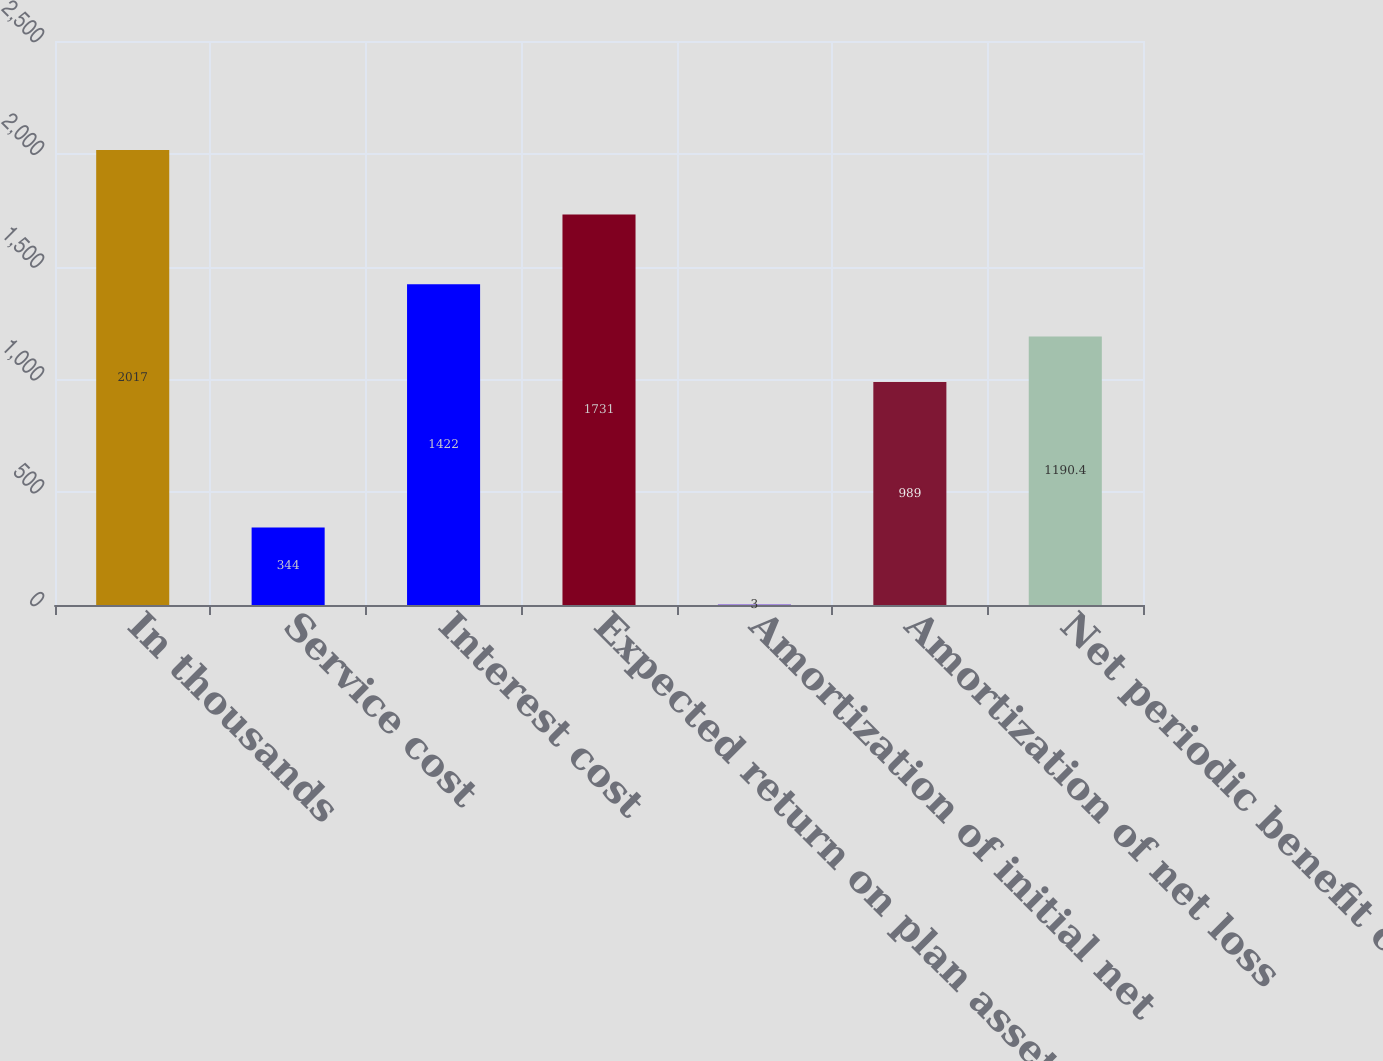Convert chart. <chart><loc_0><loc_0><loc_500><loc_500><bar_chart><fcel>In thousands<fcel>Service cost<fcel>Interest cost<fcel>Expected return on plan assets<fcel>Amortization of initial net<fcel>Amortization of net loss<fcel>Net periodic benefit cost<nl><fcel>2017<fcel>344<fcel>1422<fcel>1731<fcel>3<fcel>989<fcel>1190.4<nl></chart> 